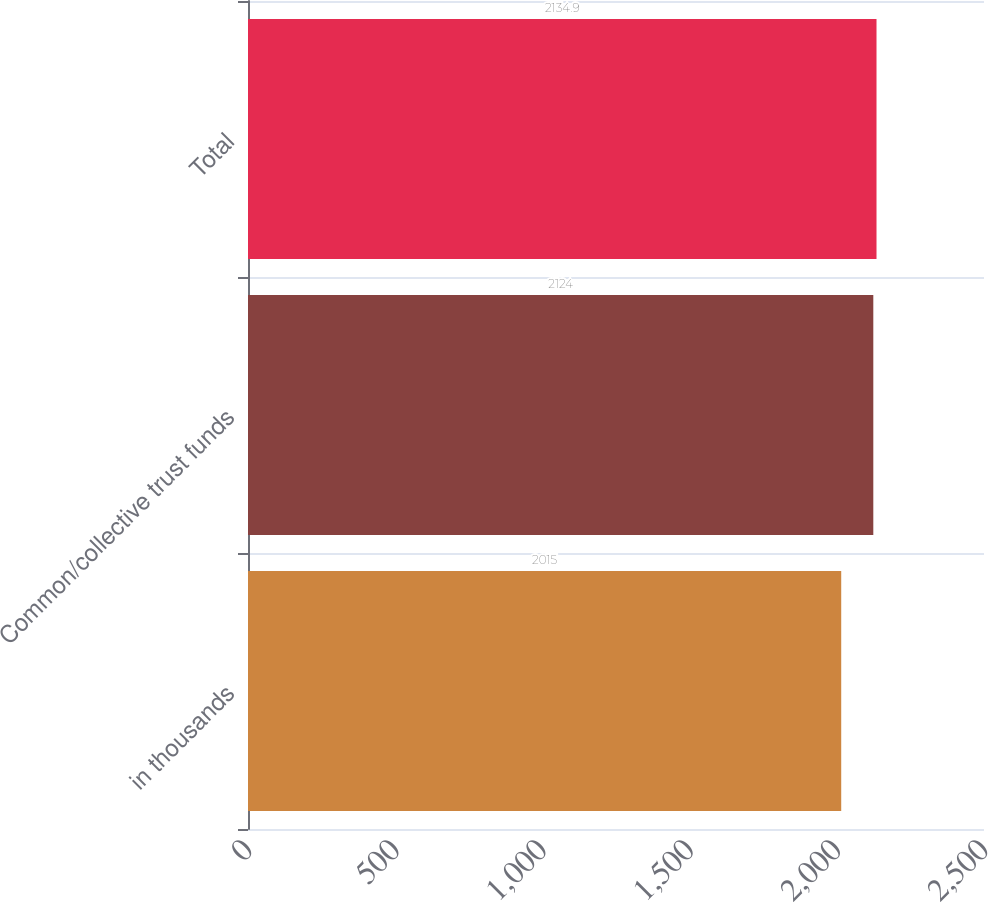Convert chart to OTSL. <chart><loc_0><loc_0><loc_500><loc_500><bar_chart><fcel>in thousands<fcel>Common/collective trust funds<fcel>Total<nl><fcel>2015<fcel>2124<fcel>2134.9<nl></chart> 